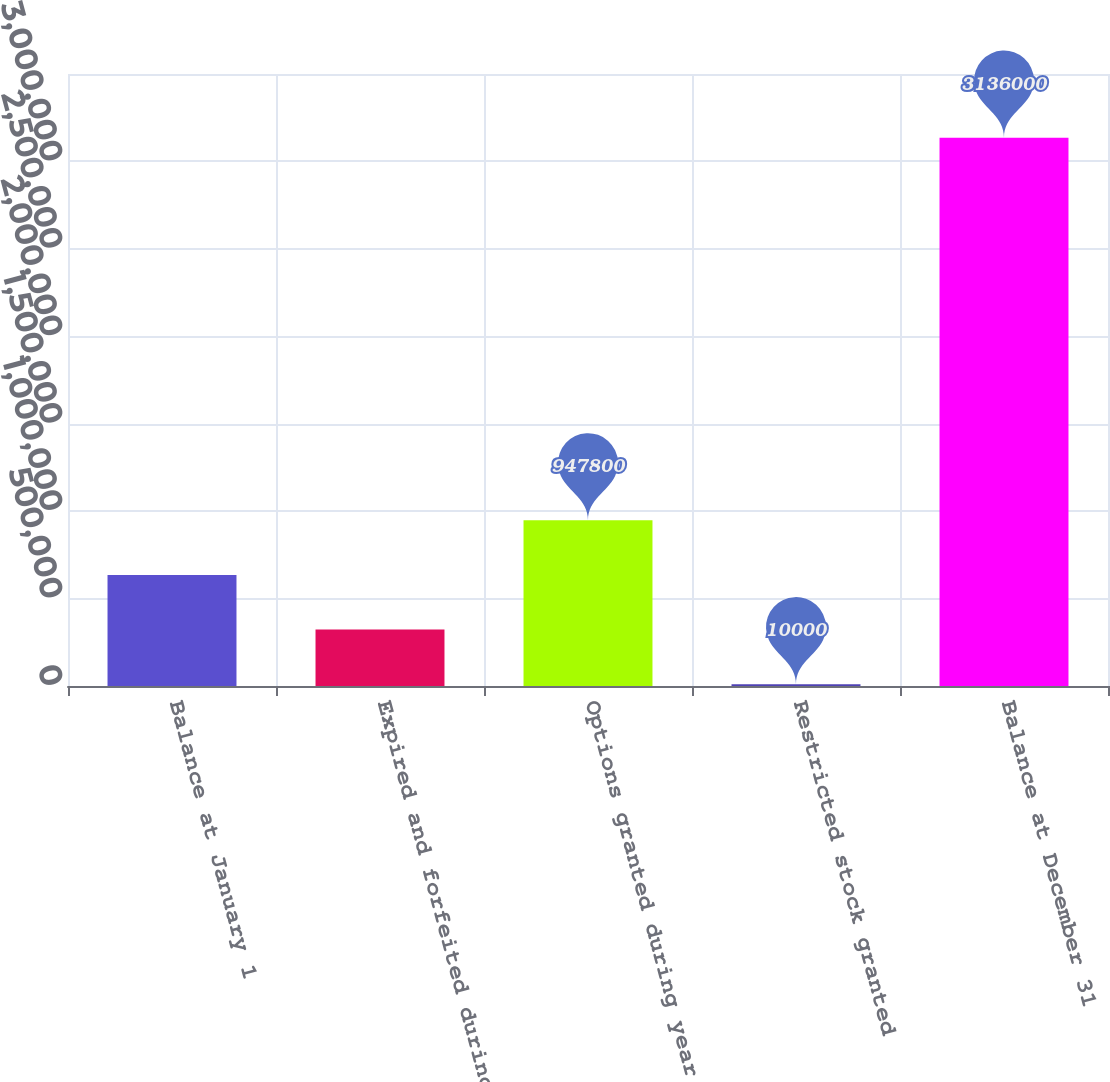Convert chart. <chart><loc_0><loc_0><loc_500><loc_500><bar_chart><fcel>Balance at January 1<fcel>Expired and forfeited during<fcel>Options granted during year<fcel>Restricted stock granted<fcel>Balance at December 31<nl><fcel>635200<fcel>322600<fcel>947800<fcel>10000<fcel>3.136e+06<nl></chart> 